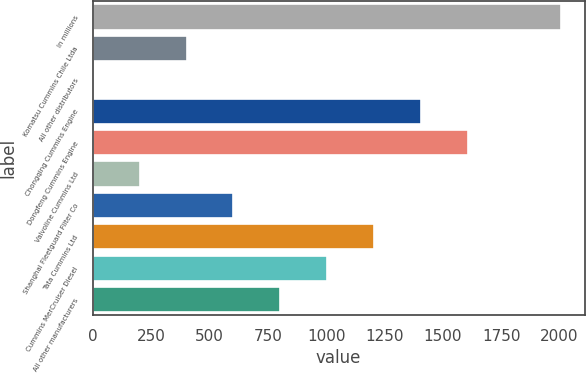<chart> <loc_0><loc_0><loc_500><loc_500><bar_chart><fcel>In millions<fcel>Komatsu Cummins Chile Ltda<fcel>All other distributors<fcel>Chongqing Cummins Engine<fcel>Dongfeng Cummins Engine<fcel>Valvoline Cummins Ltd<fcel>Shanghai Fleetguard Filter Co<fcel>Tata Cummins Ltd<fcel>Cummins MerCruiser Diesel<fcel>All other manufacturers<nl><fcel>2007<fcel>402.2<fcel>1<fcel>1405.2<fcel>1605.8<fcel>201.6<fcel>602.8<fcel>1204.6<fcel>1004<fcel>803.4<nl></chart> 